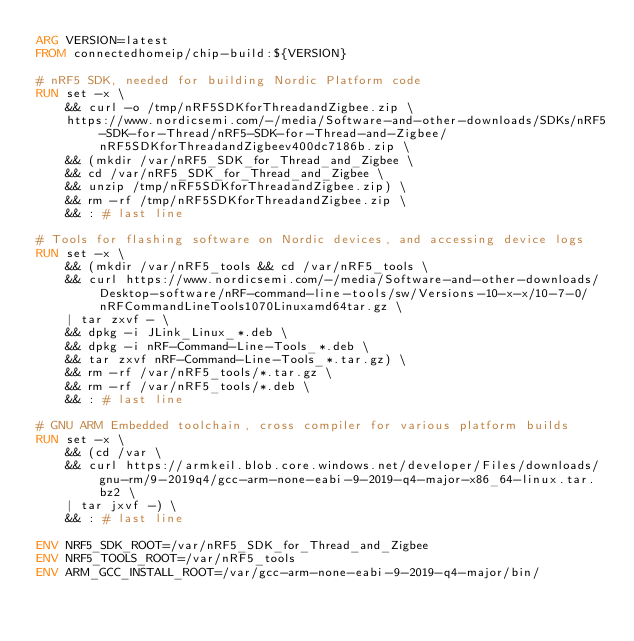Convert code to text. <code><loc_0><loc_0><loc_500><loc_500><_Dockerfile_>ARG VERSION=latest
FROM connectedhomeip/chip-build:${VERSION}

# nRF5 SDK, needed for building Nordic Platform code
RUN set -x \
    && curl -o /tmp/nRF5SDKforThreadandZigbee.zip \
    https://www.nordicsemi.com/-/media/Software-and-other-downloads/SDKs/nRF5-SDK-for-Thread/nRF5-SDK-for-Thread-and-Zigbee/nRF5SDKforThreadandZigbeev400dc7186b.zip \
    && (mkdir /var/nRF5_SDK_for_Thread_and_Zigbee \
    && cd /var/nRF5_SDK_for_Thread_and_Zigbee \
    && unzip /tmp/nRF5SDKforThreadandZigbee.zip) \
    && rm -rf /tmp/nRF5SDKforThreadandZigbee.zip \
    && : # last line

# Tools for flashing software on Nordic devices, and accessing device logs
RUN set -x \
    && (mkdir /var/nRF5_tools && cd /var/nRF5_tools \
    && curl https://www.nordicsemi.com/-/media/Software-and-other-downloads/Desktop-software/nRF-command-line-tools/sw/Versions-10-x-x/10-7-0/nRFCommandLineTools1070Linuxamd64tar.gz \
    | tar zxvf - \
    && dpkg -i JLink_Linux_*.deb \
    && dpkg -i nRF-Command-Line-Tools_*.deb \
    && tar zxvf nRF-Command-Line-Tools_*.tar.gz) \
    && rm -rf /var/nRF5_tools/*.tar.gz \
    && rm -rf /var/nRF5_tools/*.deb \
    && : # last line

# GNU ARM Embedded toolchain, cross compiler for various platform builds
RUN set -x \
    && (cd /var \
    && curl https://armkeil.blob.core.windows.net/developer/Files/downloads/gnu-rm/9-2019q4/gcc-arm-none-eabi-9-2019-q4-major-x86_64-linux.tar.bz2 \
    | tar jxvf -) \
    && : # last line

ENV NRF5_SDK_ROOT=/var/nRF5_SDK_for_Thread_and_Zigbee
ENV NRF5_TOOLS_ROOT=/var/nRF5_tools
ENV ARM_GCC_INSTALL_ROOT=/var/gcc-arm-none-eabi-9-2019-q4-major/bin/
</code> 